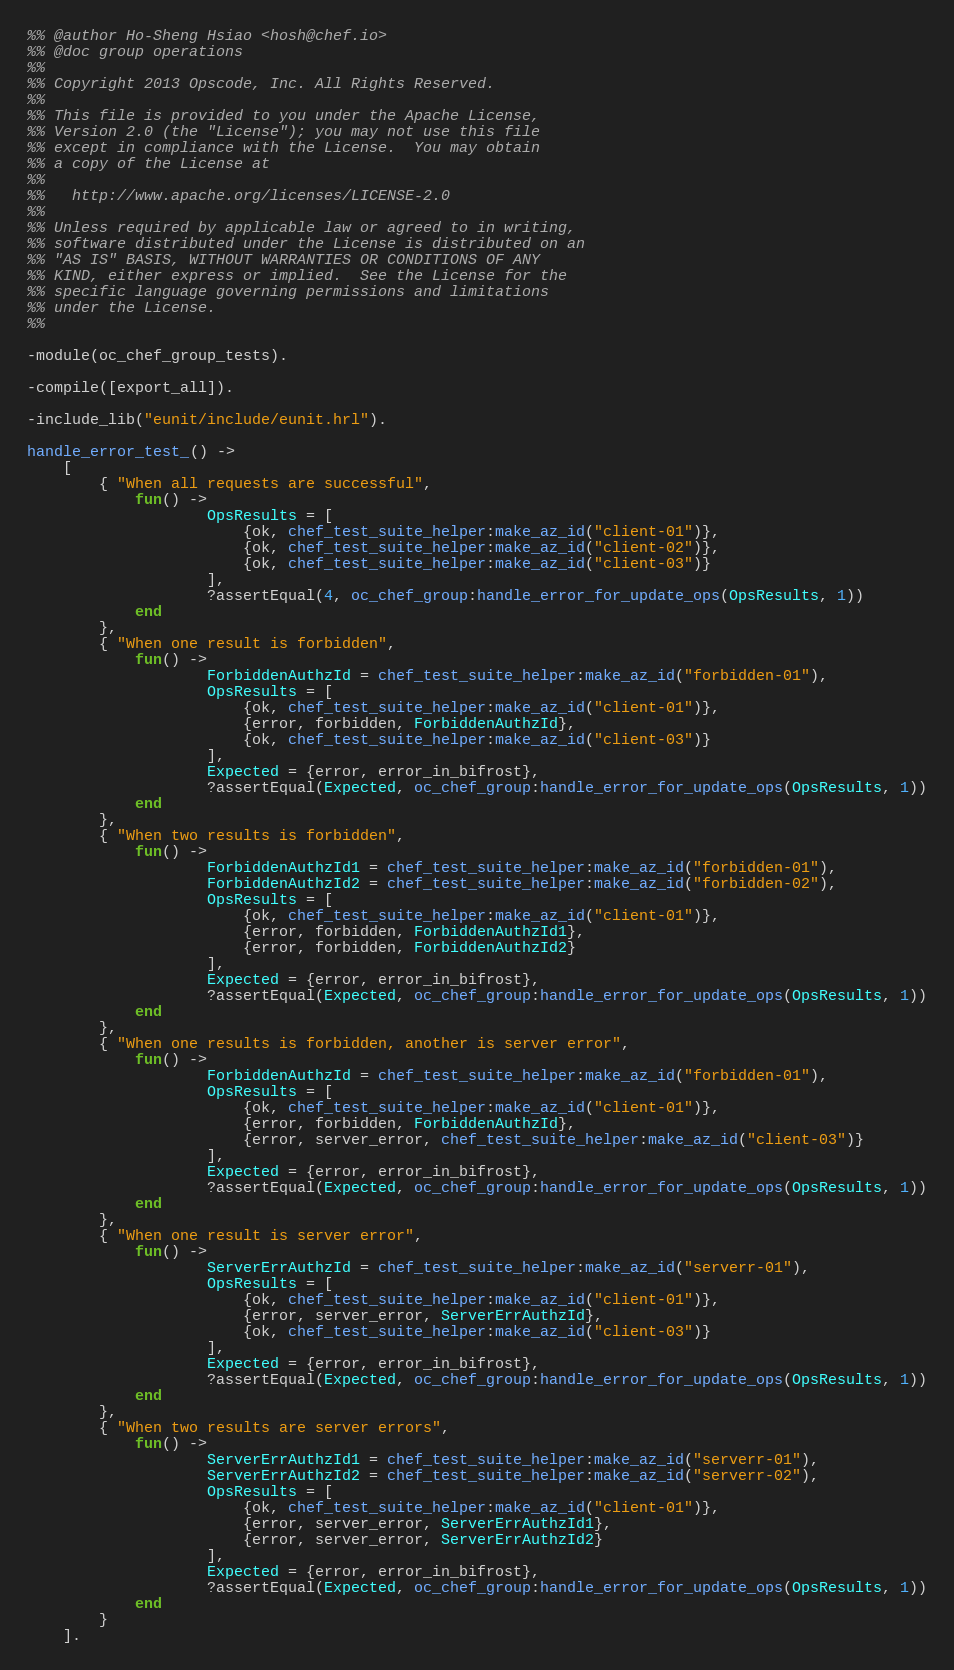Convert code to text. <code><loc_0><loc_0><loc_500><loc_500><_Erlang_>%% @author Ho-Sheng Hsiao <hosh@chef.io>
%% @doc group operations
%%
%% Copyright 2013 Opscode, Inc. All Rights Reserved.
%%
%% This file is provided to you under the Apache License,
%% Version 2.0 (the "License"); you may not use this file
%% except in compliance with the License.  You may obtain
%% a copy of the License at
%%
%%   http://www.apache.org/licenses/LICENSE-2.0
%%
%% Unless required by applicable law or agreed to in writing,
%% software distributed under the License is distributed on an
%% "AS IS" BASIS, WITHOUT WARRANTIES OR CONDITIONS OF ANY
%% KIND, either express or implied.  See the License for the
%% specific language governing permissions and limitations
%% under the License.
%%

-module(oc_chef_group_tests).

-compile([export_all]).

-include_lib("eunit/include/eunit.hrl").

handle_error_test_() ->
    [
        { "When all requests are successful",
            fun() ->
                    OpsResults = [
                        {ok, chef_test_suite_helper:make_az_id("client-01")},
                        {ok, chef_test_suite_helper:make_az_id("client-02")},
                        {ok, chef_test_suite_helper:make_az_id("client-03")}
                    ],
                    ?assertEqual(4, oc_chef_group:handle_error_for_update_ops(OpsResults, 1))
            end
        },
        { "When one result is forbidden",
            fun() ->
                    ForbiddenAuthzId = chef_test_suite_helper:make_az_id("forbidden-01"),
                    OpsResults = [
                        {ok, chef_test_suite_helper:make_az_id("client-01")},
                        {error, forbidden, ForbiddenAuthzId},
                        {ok, chef_test_suite_helper:make_az_id("client-03")}
                    ],
                    Expected = {error, error_in_bifrost},
                    ?assertEqual(Expected, oc_chef_group:handle_error_for_update_ops(OpsResults, 1))
            end
        },
        { "When two results is forbidden",
            fun() ->
                    ForbiddenAuthzId1 = chef_test_suite_helper:make_az_id("forbidden-01"),
                    ForbiddenAuthzId2 = chef_test_suite_helper:make_az_id("forbidden-02"),
                    OpsResults = [
                        {ok, chef_test_suite_helper:make_az_id("client-01")},
                        {error, forbidden, ForbiddenAuthzId1},
                        {error, forbidden, ForbiddenAuthzId2}
                    ],
                    Expected = {error, error_in_bifrost},
                    ?assertEqual(Expected, oc_chef_group:handle_error_for_update_ops(OpsResults, 1))
            end
        },
        { "When one results is forbidden, another is server error",
            fun() ->
                    ForbiddenAuthzId = chef_test_suite_helper:make_az_id("forbidden-01"),
                    OpsResults = [
                        {ok, chef_test_suite_helper:make_az_id("client-01")},
                        {error, forbidden, ForbiddenAuthzId},
                        {error, server_error, chef_test_suite_helper:make_az_id("client-03")}
                    ],
                    Expected = {error, error_in_bifrost},
                    ?assertEqual(Expected, oc_chef_group:handle_error_for_update_ops(OpsResults, 1))
            end
        },
        { "When one result is server error",
            fun() ->
                    ServerErrAuthzId = chef_test_suite_helper:make_az_id("serverr-01"),
                    OpsResults = [
                        {ok, chef_test_suite_helper:make_az_id("client-01")},
                        {error, server_error, ServerErrAuthzId},
                        {ok, chef_test_suite_helper:make_az_id("client-03")}
                    ],
                    Expected = {error, error_in_bifrost},
                    ?assertEqual(Expected, oc_chef_group:handle_error_for_update_ops(OpsResults, 1))
            end
        },
        { "When two results are server errors",
            fun() ->
                    ServerErrAuthzId1 = chef_test_suite_helper:make_az_id("serverr-01"),
                    ServerErrAuthzId2 = chef_test_suite_helper:make_az_id("serverr-02"),
                    OpsResults = [
                        {ok, chef_test_suite_helper:make_az_id("client-01")},
                        {error, server_error, ServerErrAuthzId1},
                        {error, server_error, ServerErrAuthzId2}
                    ],
                    Expected = {error, error_in_bifrost},
                    ?assertEqual(Expected, oc_chef_group:handle_error_for_update_ops(OpsResults, 1))
            end
        }
    ].

</code> 